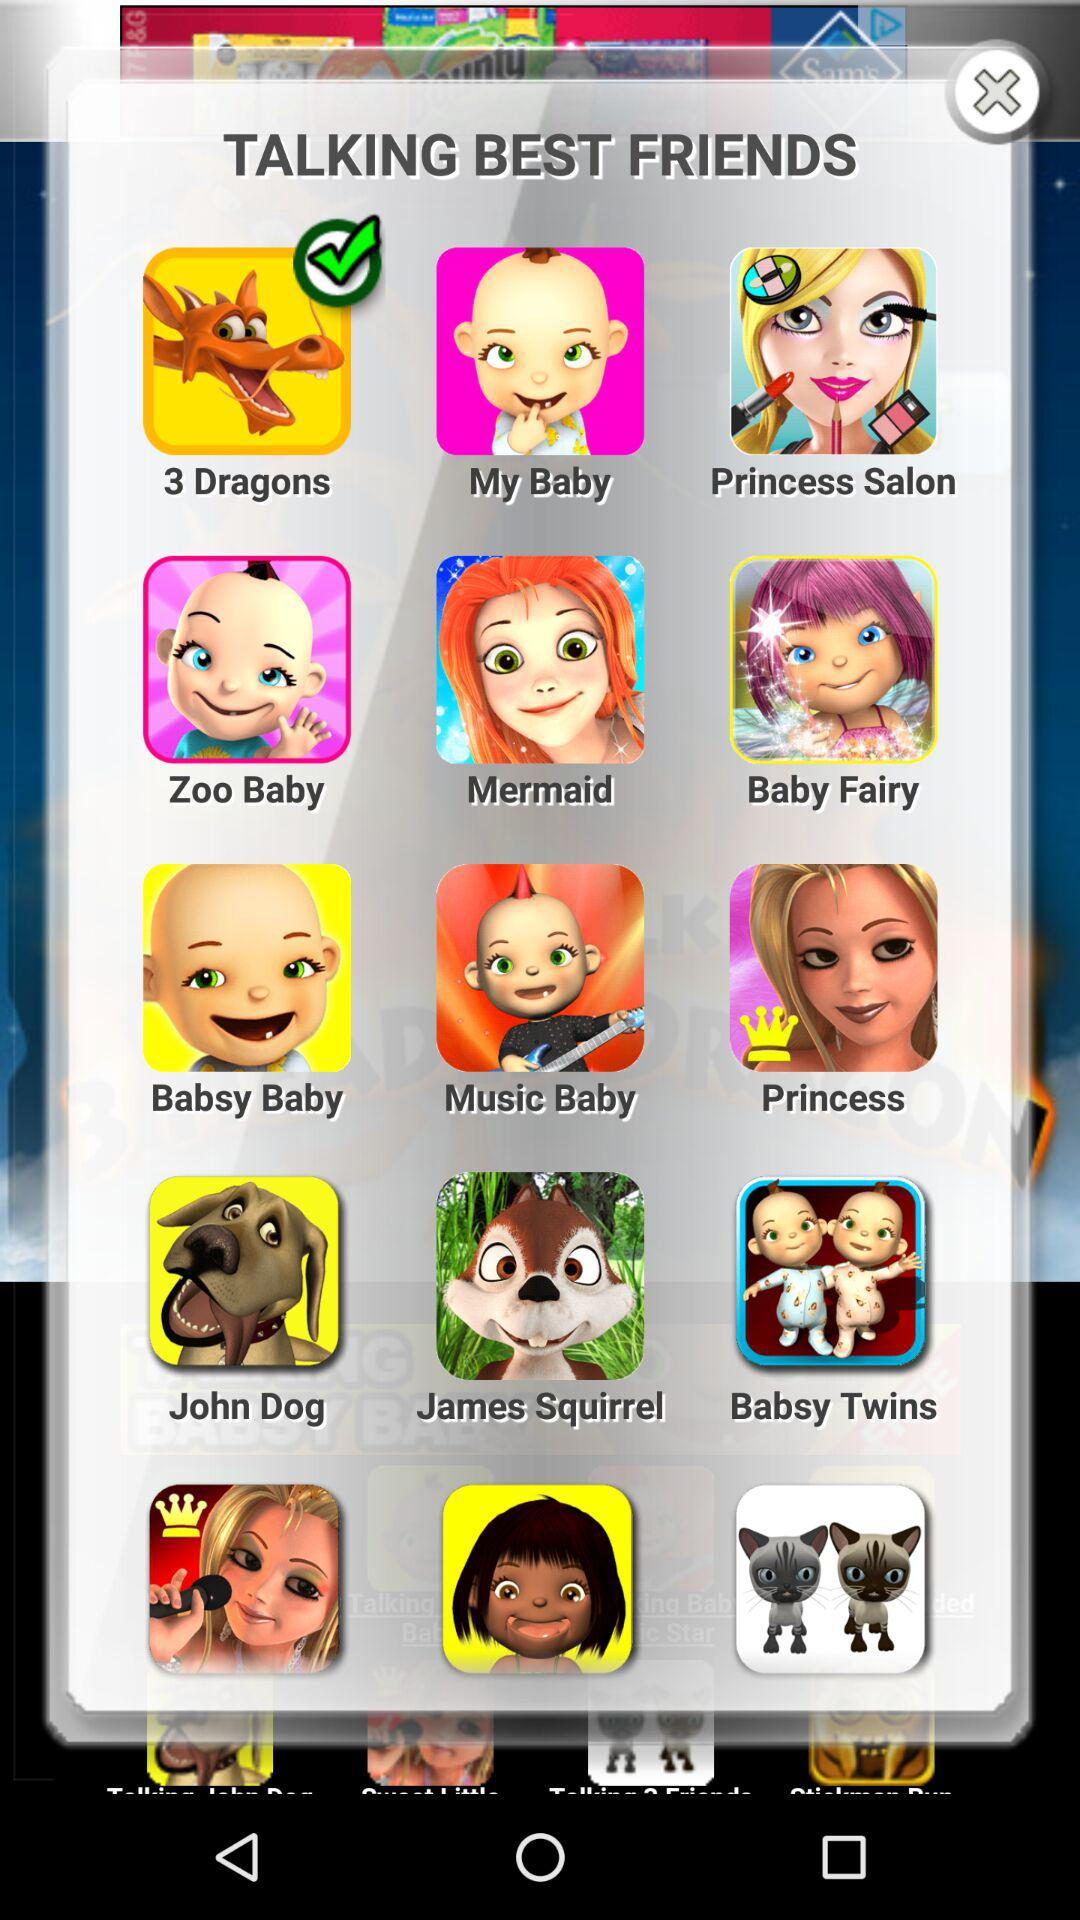Which talking best friend is selected? The selected talking best friend is "3 Dragons". 